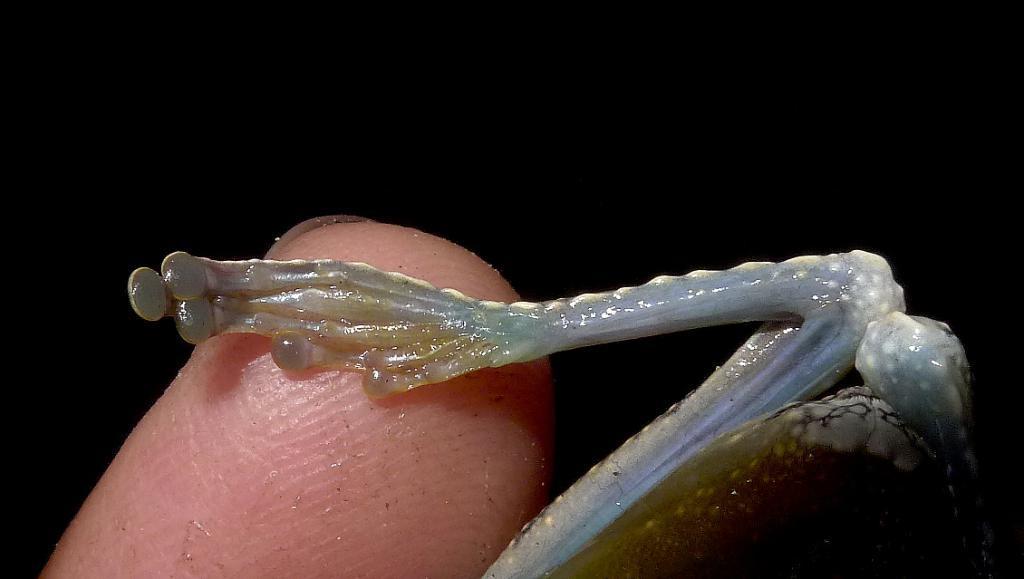Could you give a brief overview of what you see in this image? In this image in the center there is one person's finger is visible, and on the right side there is one insect. 